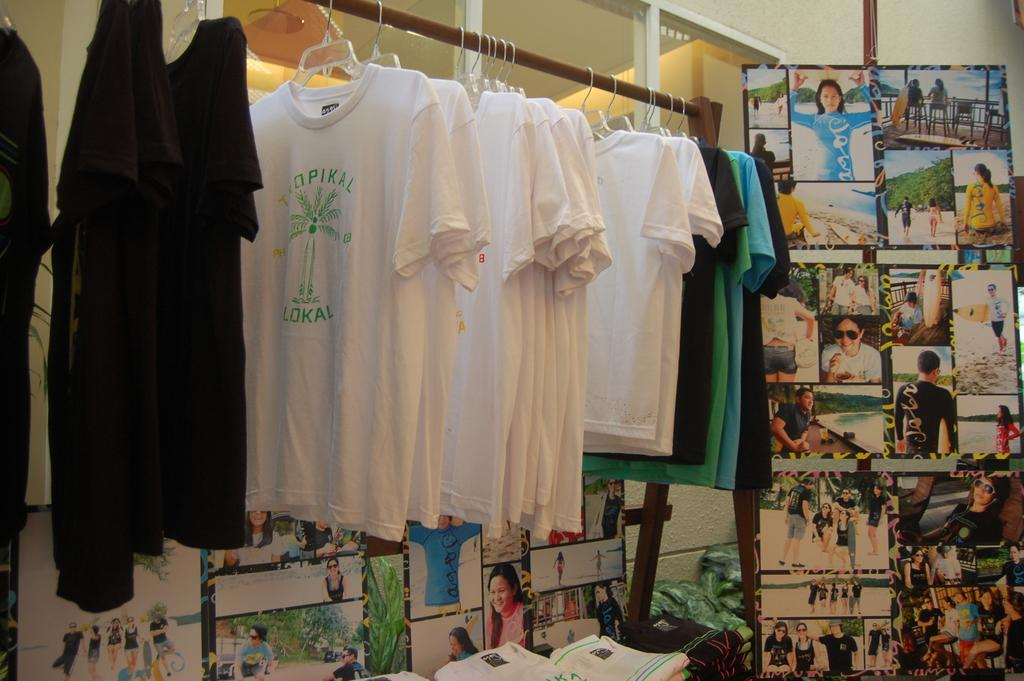What can be seen hanging on the hangers in the image? There are clothes on hangers in the image. What other objects are present in the image besides the clothes? There are boards and posters in the image. What can be seen in the background of the image? There is a wall and glasses visible in the background of the image. How many eyes can be seen on the clothes in the image? There are no eyes visible on the clothes in the image, as clothes do not have eyes. 